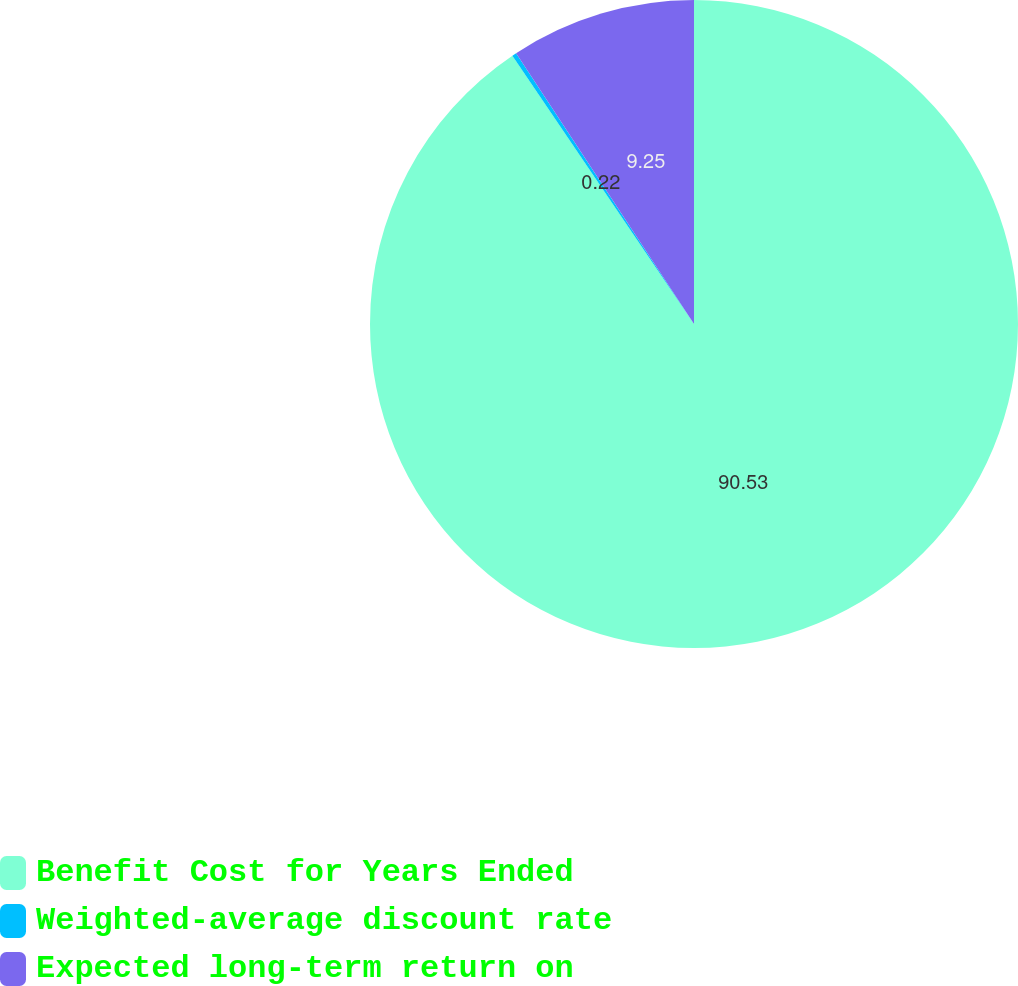<chart> <loc_0><loc_0><loc_500><loc_500><pie_chart><fcel>Benefit Cost for Years Ended<fcel>Weighted-average discount rate<fcel>Expected long-term return on<nl><fcel>90.52%<fcel>0.22%<fcel>9.25%<nl></chart> 